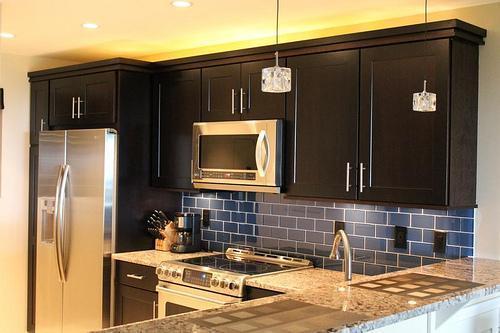How many microwaves are there?
Give a very brief answer. 1. 